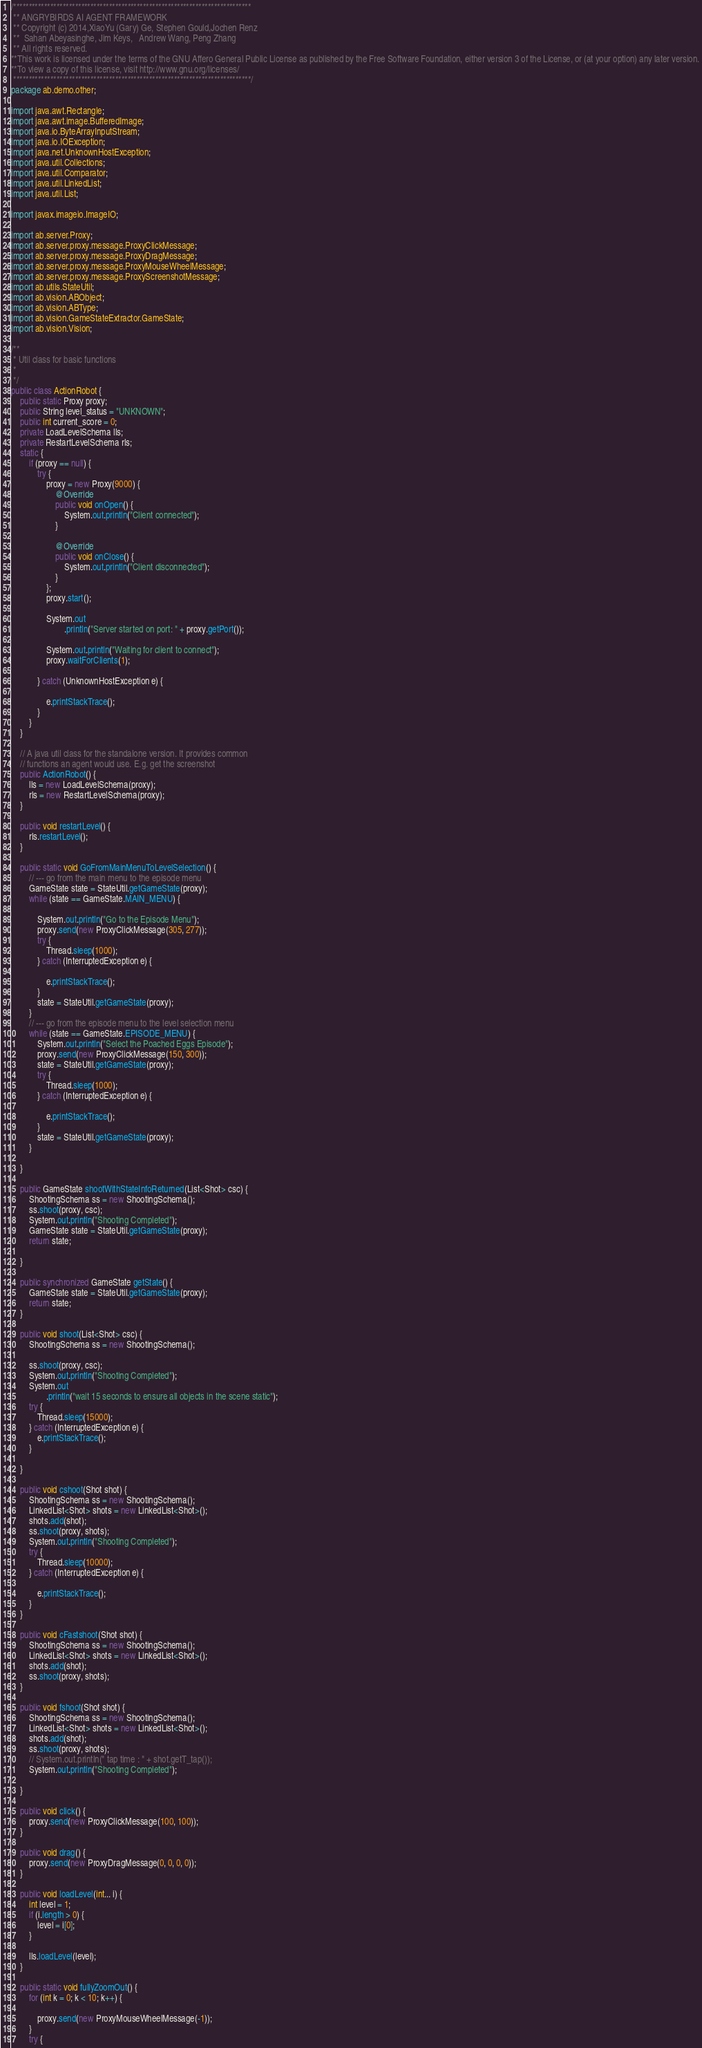Convert code to text. <code><loc_0><loc_0><loc_500><loc_500><_Java_>/*****************************************************************************
 ** ANGRYBIRDS AI AGENT FRAMEWORK
 ** Copyright (c) 2014,XiaoYu (Gary) Ge, Stephen Gould,Jochen Renz
 **  Sahan Abeyasinghe, Jim Keys,   Andrew Wang, Peng Zhang
 ** All rights reserved.
**This work is licensed under the terms of the GNU Affero General Public License as published by the Free Software Foundation, either version 3 of the License, or (at your option) any later version.
**To view a copy of this license, visit http://www.gnu.org/licenses/
 *****************************************************************************/
package ab.demo.other;

import java.awt.Rectangle;
import java.awt.image.BufferedImage;
import java.io.ByteArrayInputStream;
import java.io.IOException;
import java.net.UnknownHostException;
import java.util.Collections;
import java.util.Comparator;
import java.util.LinkedList;
import java.util.List;

import javax.imageio.ImageIO;

import ab.server.Proxy;
import ab.server.proxy.message.ProxyClickMessage;
import ab.server.proxy.message.ProxyDragMessage;
import ab.server.proxy.message.ProxyMouseWheelMessage;
import ab.server.proxy.message.ProxyScreenshotMessage;
import ab.utils.StateUtil;
import ab.vision.ABObject;
import ab.vision.ABType;
import ab.vision.GameStateExtractor.GameState;
import ab.vision.Vision;

/**
 * Util class for basic functions
 * 
 */
public class ActionRobot {
	public static Proxy proxy;
	public String level_status = "UNKNOWN";
	public int current_score = 0;
	private LoadLevelSchema lls;
	private RestartLevelSchema rls;
	static {
		if (proxy == null) {
			try {
				proxy = new Proxy(9000) {
					@Override
					public void onOpen() {
						System.out.println("Client connected");
					}

					@Override
					public void onClose() {
						System.out.println("Client disconnected");
					}
				};
				proxy.start();

				System.out
						.println("Server started on port: " + proxy.getPort());

				System.out.println("Waiting for client to connect");
				proxy.waitForClients(1);

			} catch (UnknownHostException e) {

				e.printStackTrace();
			}
		}
	}

	// A java util class for the standalone version. It provides common
	// functions an agent would use. E.g. get the screenshot
	public ActionRobot() {
		lls = new LoadLevelSchema(proxy);
		rls = new RestartLevelSchema(proxy);
	}

	public void restartLevel() {
		rls.restartLevel();
	}

	public static void GoFromMainMenuToLevelSelection() {
		// --- go from the main menu to the episode menu
		GameState state = StateUtil.getGameState(proxy);
		while (state == GameState.MAIN_MENU) {

			System.out.println("Go to the Episode Menu");
			proxy.send(new ProxyClickMessage(305, 277));
			try {
				Thread.sleep(1000);
			} catch (InterruptedException e) {

				e.printStackTrace();
			}
			state = StateUtil.getGameState(proxy);
		}
		// --- go from the episode menu to the level selection menu
		while (state == GameState.EPISODE_MENU) {
			System.out.println("Select the Poached Eggs Episode");
			proxy.send(new ProxyClickMessage(150, 300));
			state = StateUtil.getGameState(proxy);
			try {
				Thread.sleep(1000);
			} catch (InterruptedException e) {

				e.printStackTrace();
			}
			state = StateUtil.getGameState(proxy);
		}

	}

	public GameState shootWithStateInfoReturned(List<Shot> csc) {
		ShootingSchema ss = new ShootingSchema();
		ss.shoot(proxy, csc);
		System.out.println("Shooting Completed");
		GameState state = StateUtil.getGameState(proxy);
		return state;

	}

	public synchronized GameState getState() {
		GameState state = StateUtil.getGameState(proxy);
		return state;
	}

	public void shoot(List<Shot> csc) {
		ShootingSchema ss = new ShootingSchema();

		ss.shoot(proxy, csc);
		System.out.println("Shooting Completed");
		System.out
				.println("wait 15 seconds to ensure all objects in the scene static");
		try {
			Thread.sleep(15000);
		} catch (InterruptedException e) {
			e.printStackTrace();
		}

	}

	public void cshoot(Shot shot) {
		ShootingSchema ss = new ShootingSchema();
		LinkedList<Shot> shots = new LinkedList<Shot>();
		shots.add(shot);
		ss.shoot(proxy, shots);
		System.out.println("Shooting Completed");
		try {
			Thread.sleep(10000);
		} catch (InterruptedException e) {

			e.printStackTrace();
		}
	}

	public void cFastshoot(Shot shot) {
		ShootingSchema ss = new ShootingSchema();
		LinkedList<Shot> shots = new LinkedList<Shot>();
		shots.add(shot);
		ss.shoot(proxy, shots);
	}

	public void fshoot(Shot shot) {
		ShootingSchema ss = new ShootingSchema();
		LinkedList<Shot> shots = new LinkedList<Shot>();
		shots.add(shot);
		ss.shoot(proxy, shots);
		// System.out.println(" tap time : " + shot.getT_tap());
		System.out.println("Shooting Completed");

	}

	public void click() {
		proxy.send(new ProxyClickMessage(100, 100));
	}

	public void drag() {
		proxy.send(new ProxyDragMessage(0, 0, 0, 0));
	}

	public void loadLevel(int... i) {
		int level = 1;
		if (i.length > 0) {
			level = i[0];
		}

		lls.loadLevel(level);
	}

	public static void fullyZoomOut() {
		for (int k = 0; k < 10; k++) {

			proxy.send(new ProxyMouseWheelMessage(-1));
		}
		try {</code> 